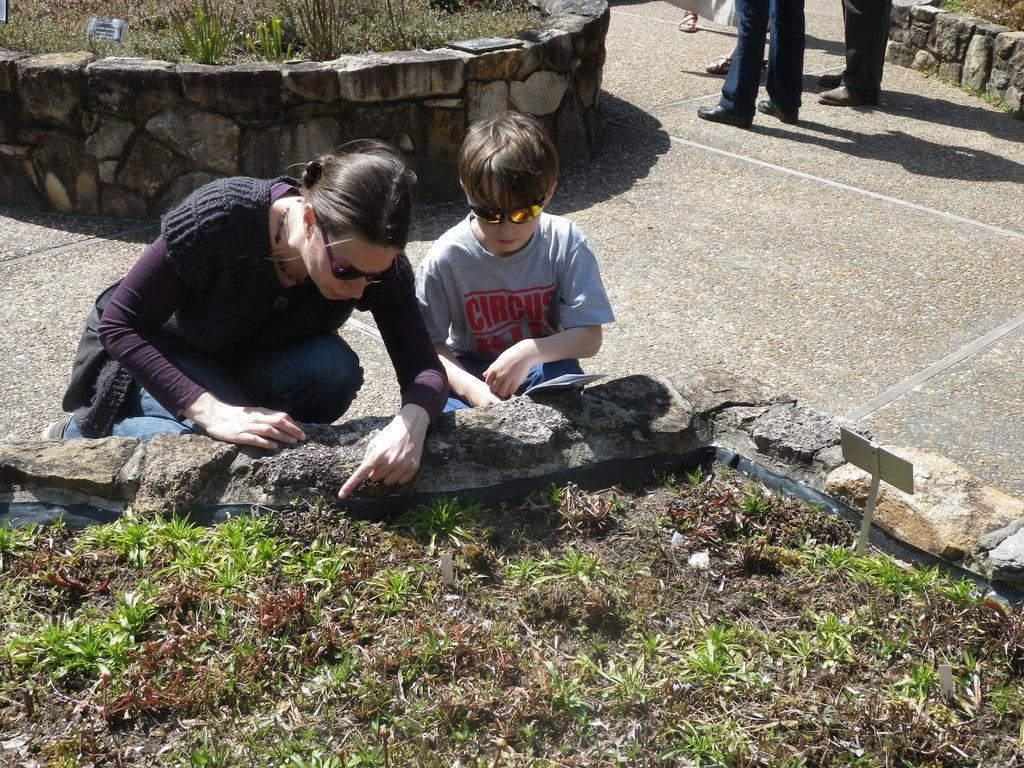How many people are present in the image? There are two persons in the image: a woman and a boy. What is the woman and the boy doing in the image? They are interacting with the soil and plants in the image. What is growing in the soil? There are plants growing in the soil. Can you describe the background of the image? There are other people standing in the background of the image. What type of breakfast is the woman preparing for the boy in the image? There is no indication of breakfast or food preparation in the image; it primarily focuses on the woman and the boy interacting with the soil and plants. 